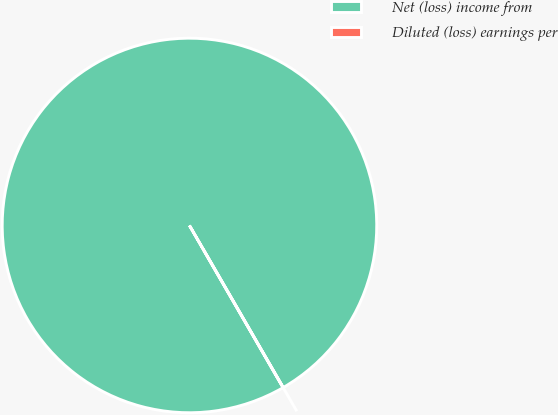<chart> <loc_0><loc_0><loc_500><loc_500><pie_chart><fcel>Net (loss) income from<fcel>Diluted (loss) earnings per<nl><fcel>100.0%<fcel>0.0%<nl></chart> 